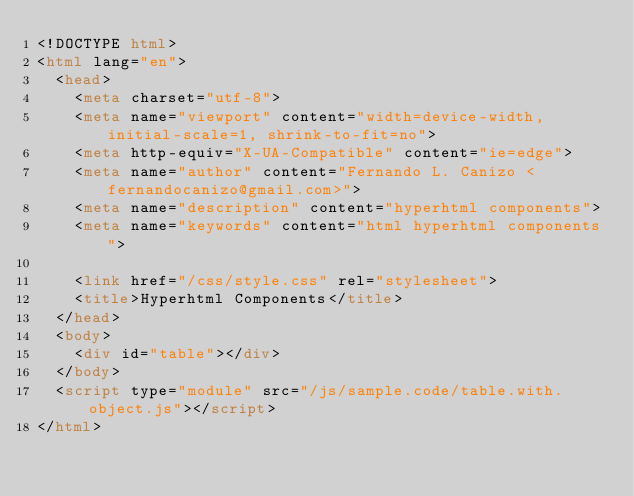Convert code to text. <code><loc_0><loc_0><loc_500><loc_500><_HTML_><!DOCTYPE html>
<html lang="en">
  <head>
    <meta charset="utf-8">
    <meta name="viewport" content="width=device-width, initial-scale=1, shrink-to-fit=no">
    <meta http-equiv="X-UA-Compatible" content="ie=edge">
    <meta name="author" content="Fernando L. Canizo <fernandocanizo@gmail.com>">
    <meta name="description" content="hyperhtml components">
    <meta name="keywords" content="html hyperhtml components">

    <link href="/css/style.css" rel="stylesheet">
    <title>Hyperhtml Components</title>
  </head>
  <body>
    <div id="table"></div>
  </body>
  <script type="module" src="/js/sample.code/table.with.object.js"></script>
</html>
</code> 